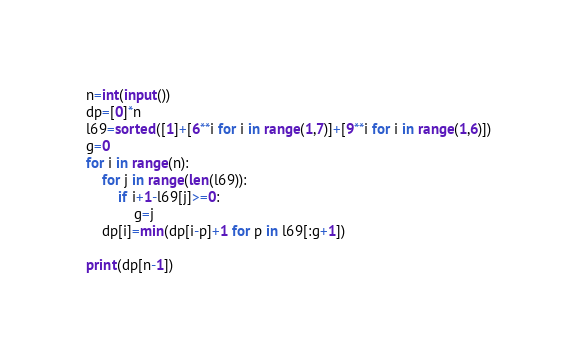<code> <loc_0><loc_0><loc_500><loc_500><_Python_>n=int(input())
dp=[0]*n
l69=sorted([1]+[6**i for i in range(1,7)]+[9**i for i in range(1,6)])
g=0
for i in range(n):
    for j in range(len(l69)):
        if i+1-l69[j]>=0:
            g=j
    dp[i]=min(dp[i-p]+1 for p in l69[:g+1])

print(dp[n-1])</code> 